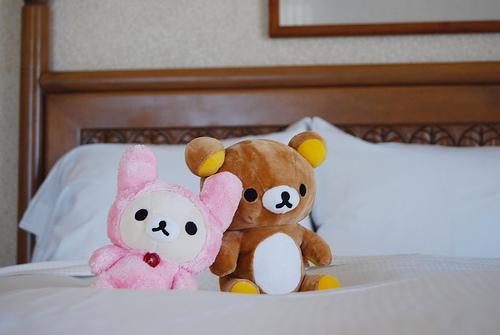How many pillows are on the bed?
Short answer required. 2. Is this a toy?
Quick response, please. Yes. What color is the bear?
Answer briefly. Brown. What color are the pillows?
Answer briefly. White. Do these stuffed animals have names?
Quick response, please. Yes. Is this a baby's bed?
Write a very short answer. No. Are they touching?
Write a very short answer. Yes. Is this a baby crib?
Be succinct. No. 